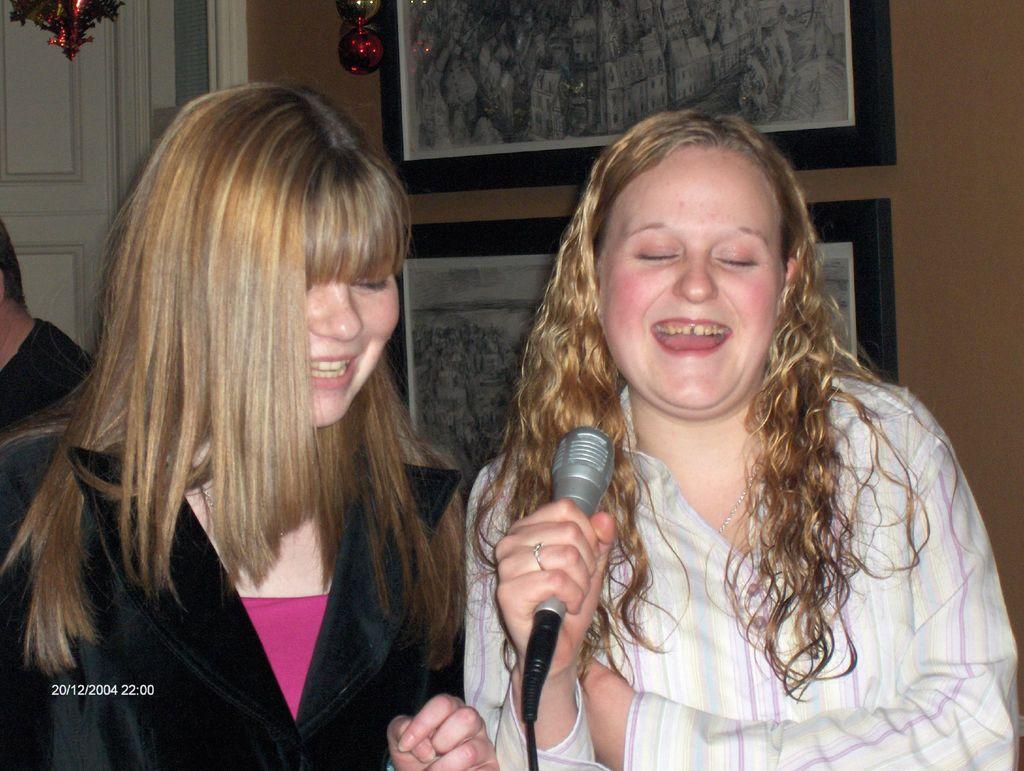How many people are in the image? There are two persons in the image. What expressions do the people in the image have? Both persons are smiling. What is the woman on the right side holding? The woman on the right side is holding a microphone. What can be seen in the background of the image? There is a door, at least one person, photo frames, a wall, and a decorative item visible in the background. What force is being applied to the cup in the image? There is no cup present in the image, so no force can be applied to it. 